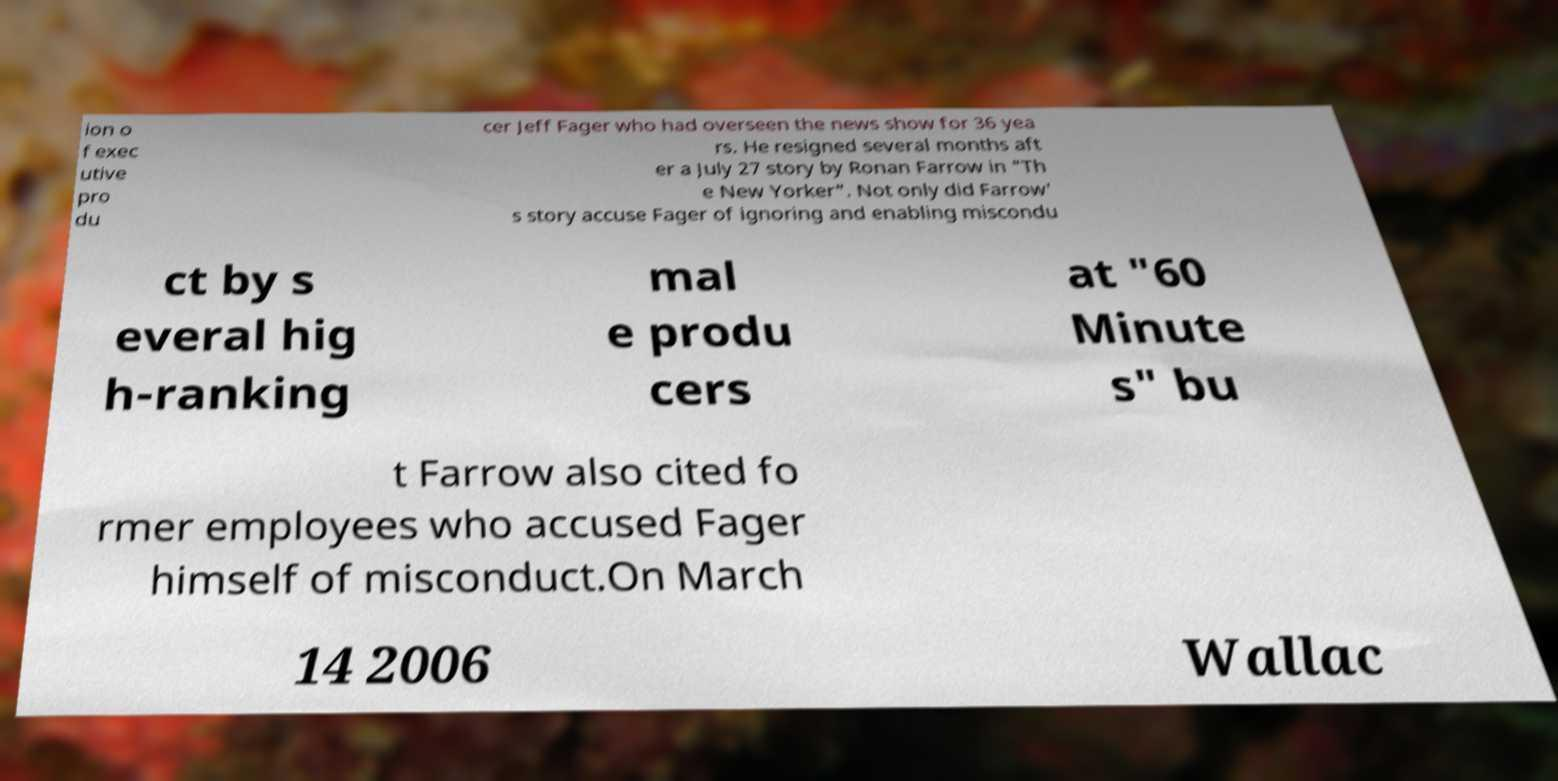I need the written content from this picture converted into text. Can you do that? ion o f exec utive pro du cer Jeff Fager who had overseen the news show for 36 yea rs. He resigned several months aft er a July 27 story by Ronan Farrow in "Th e New Yorker". Not only did Farrow' s story accuse Fager of ignoring and enabling miscondu ct by s everal hig h-ranking mal e produ cers at "60 Minute s" bu t Farrow also cited fo rmer employees who accused Fager himself of misconduct.On March 14 2006 Wallac 